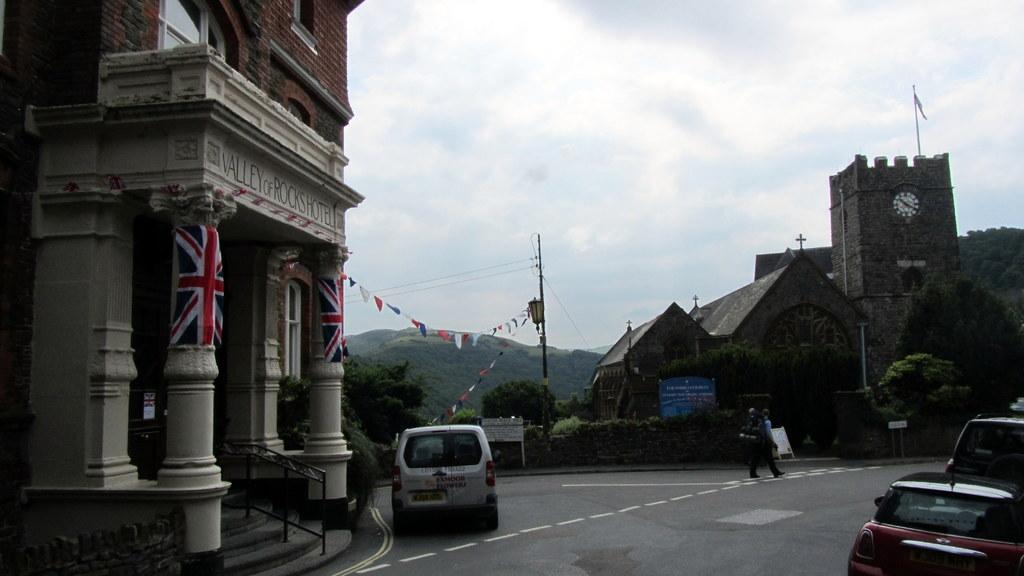<image>
Offer a succinct explanation of the picture presented. A city intersection showing the Valley of Rocks hotel. 